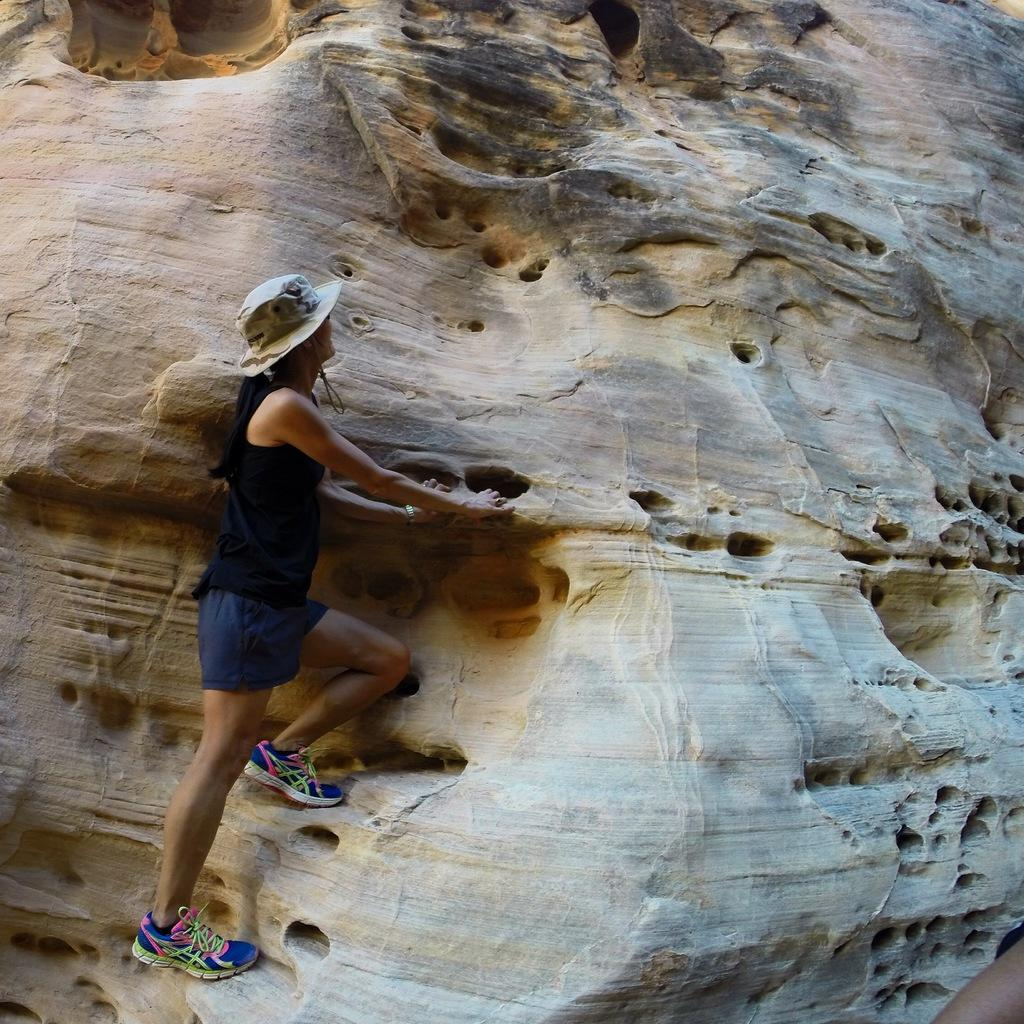What is the main subject of the image? There is a person in the image. Where is the person located in the image? The person is standing on a rock. What is the person wearing on their head? The person is wearing a hat. What language is being spoken by the person in the image? There is no indication of the person speaking in the image, so it cannot be determined what language they might be speaking. 